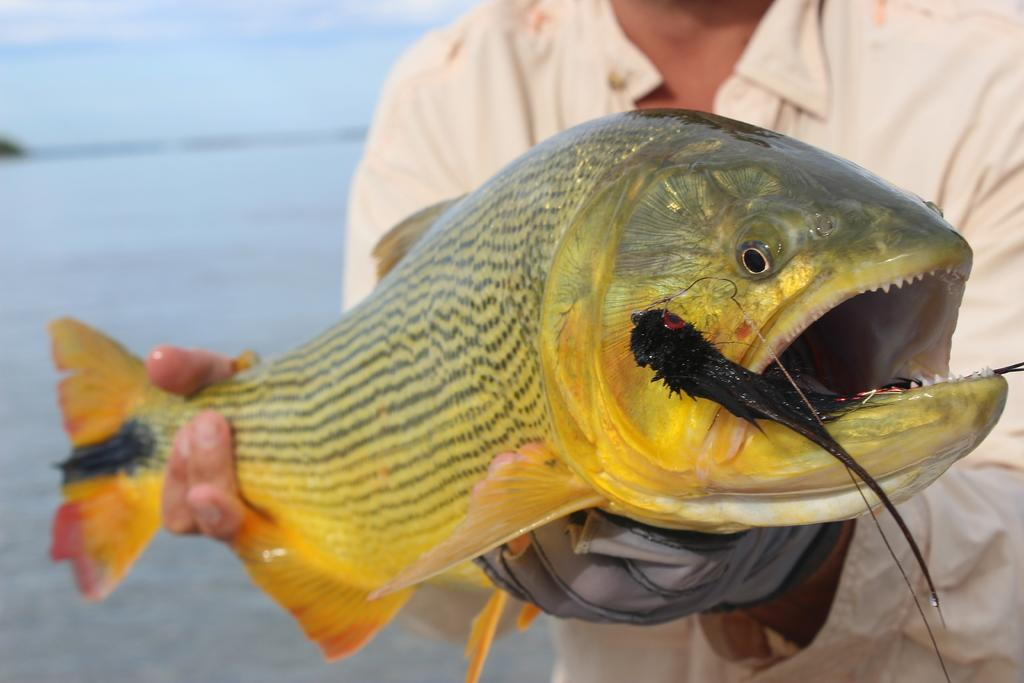What is the person in the image holding? The person is holding a fish. What can be seen in the background of the image? There is water and the sky visible in the background of the image. What type of skin can be seen on the tin in the image? There is no tin or skin present in the image. How many boots are visible in the image? There are no boots visible in the image. 